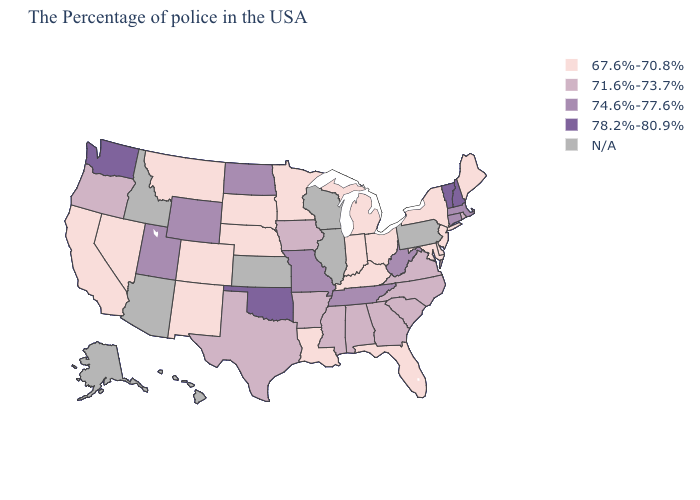Does the map have missing data?
Keep it brief. Yes. Does Oklahoma have the highest value in the South?
Short answer required. Yes. Which states hav the highest value in the West?
Concise answer only. Washington. What is the highest value in the USA?
Be succinct. 78.2%-80.9%. What is the value of Ohio?
Quick response, please. 67.6%-70.8%. What is the lowest value in states that border Maryland?
Concise answer only. 67.6%-70.8%. Among the states that border Virginia , does Maryland have the highest value?
Quick response, please. No. How many symbols are there in the legend?
Write a very short answer. 5. Name the states that have a value in the range 78.2%-80.9%?
Short answer required. New Hampshire, Vermont, Oklahoma, Washington. Name the states that have a value in the range 67.6%-70.8%?
Concise answer only. Maine, New York, New Jersey, Delaware, Maryland, Ohio, Florida, Michigan, Kentucky, Indiana, Louisiana, Minnesota, Nebraska, South Dakota, Colorado, New Mexico, Montana, Nevada, California. Which states have the lowest value in the South?
Be succinct. Delaware, Maryland, Florida, Kentucky, Louisiana. 